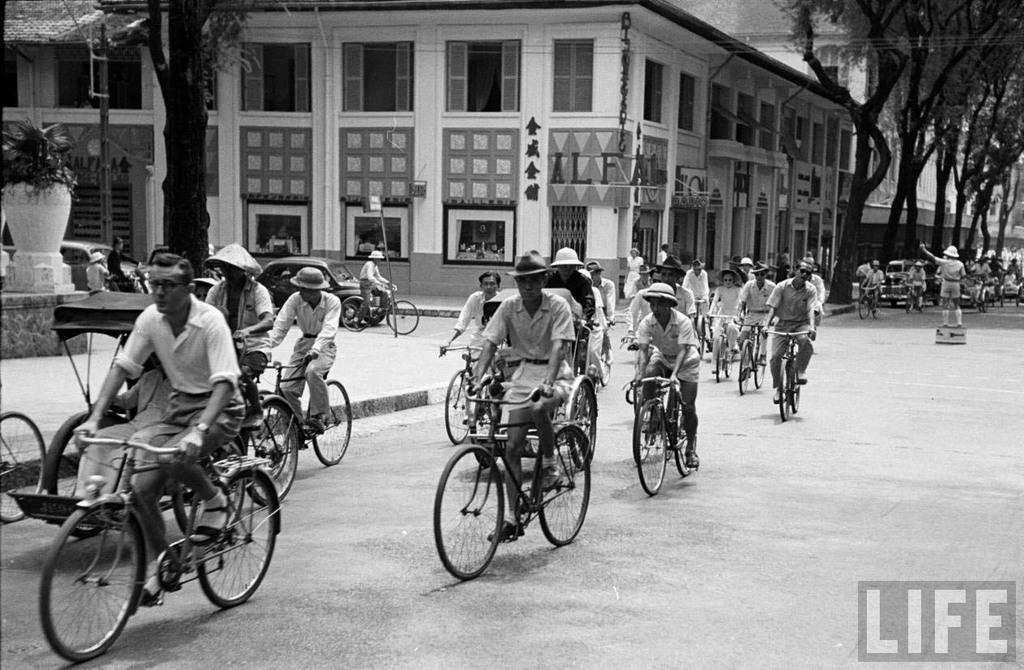What are the people in the image doing? The people in the image are riding bicycles. What can be seen in the background of the image? There is a building, cars, and trees visible in the background. What type of support can be seen for the cemetery in the image? There is no cemetery present in the image, so there is no support for a cemetery to be seen. 